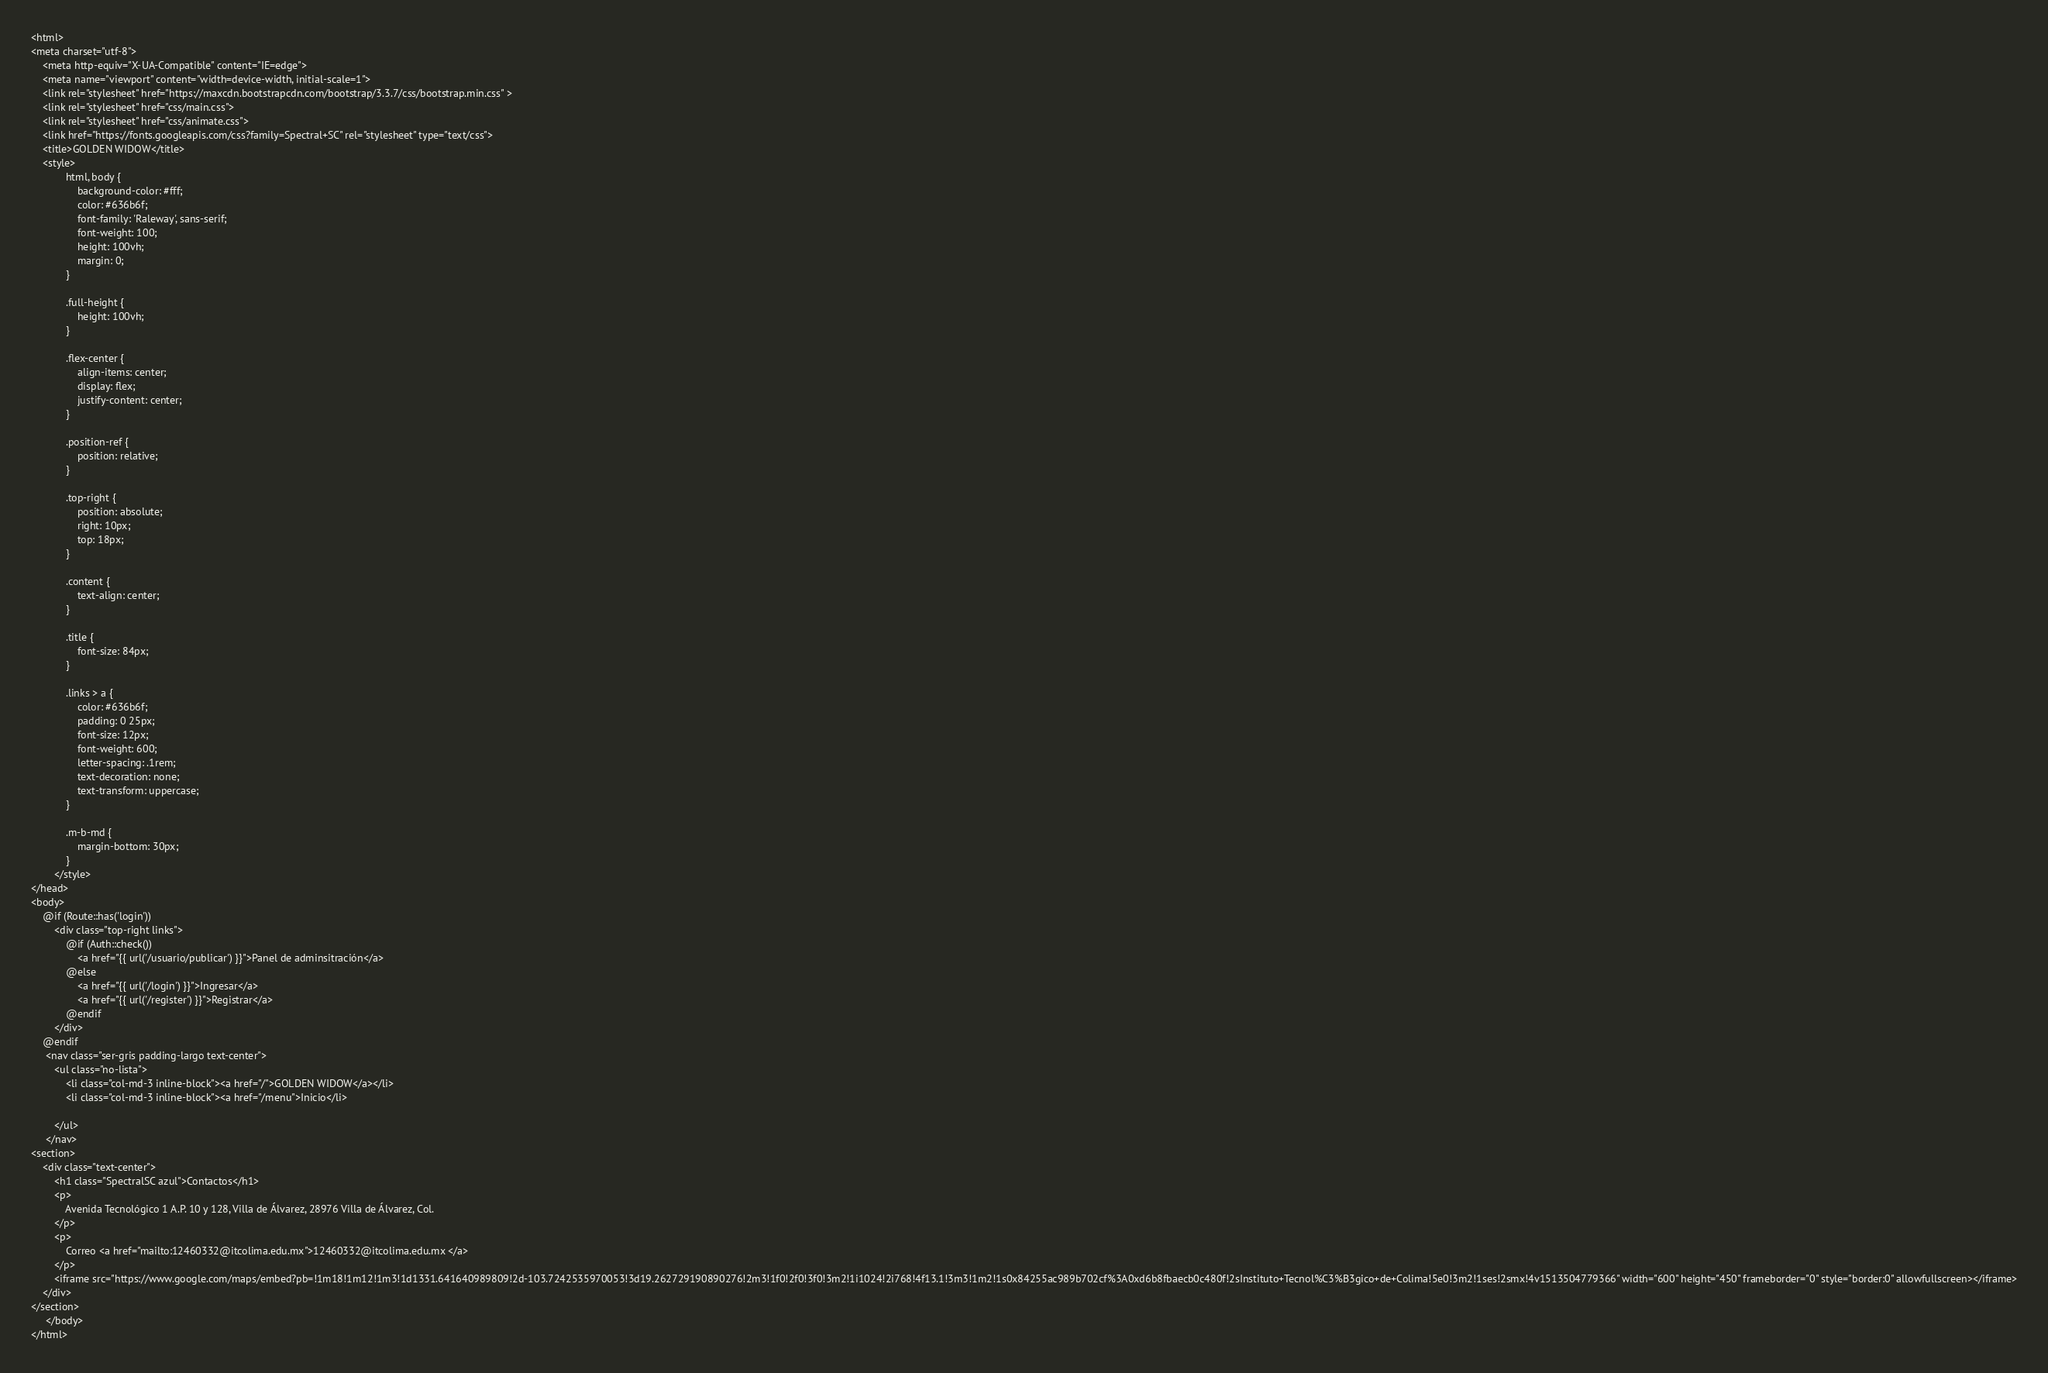<code> <loc_0><loc_0><loc_500><loc_500><_PHP_><html>
<meta charset="utf-8">
    <meta http-equiv="X-UA-Compatible" content="IE=edge">
    <meta name="viewport" content="width=device-width, initial-scale=1">
    <link rel="stylesheet" href="https://maxcdn.bootstrapcdn.com/bootstrap/3.3.7/css/bootstrap.min.css" >
    <link rel="stylesheet" href="css/main.css">
    <link rel="stylesheet" href="css/animate.css">
    <link href="https://fonts.googleapis.com/css?family=Spectral+SC" rel="stylesheet" type="text/css">
    <title>GOLDEN WIDOW</title>  
    <style>
            html, body {
                background-color: #fff;
                color: #636b6f;
                font-family: 'Raleway', sans-serif;
                font-weight: 100;
                height: 100vh;
                margin: 0;
            }

            .full-height {
                height: 100vh;
            }

            .flex-center {
                align-items: center;
                display: flex;
                justify-content: center;
            }

            .position-ref {
                position: relative;
            }

            .top-right {
                position: absolute;
                right: 10px;
                top: 18px;
            }

            .content {
                text-align: center;
            }

            .title {
                font-size: 84px;
            }

            .links > a {
                color: #636b6f;
                padding: 0 25px;
                font-size: 12px;
                font-weight: 600;
                letter-spacing: .1rem;
                text-decoration: none;
                text-transform: uppercase;
            }

            .m-b-md {
                margin-bottom: 30px;
            }
        </style>       
</head>
<body>
    @if (Route::has('login'))
        <div class="top-right links">
            @if (Auth::check())
                <a href="{{ url('/usuario/publicar') }}">Panel de adminsitración</a>
            @else
                <a href="{{ url('/login') }}">Ingresar</a>
                <a href="{{ url('/register') }}">Registrar</a>
            @endif
        </div>
    @endif
     <nav class="ser-gris padding-largo text-center">
     	<ul class="no-lista">
     		<li class="col-md-3 inline-block"><a href="/">GOLDEN WIDOW</a></li>
     		<li class="col-md-3 inline-block"><a href="/menu">Inicio</li>

     	</ul>
     </nav>
<section>
    <div class="text-center">
        <h1 class="SpectralSC azul">Contactos</h1>
        <p>
            Avenida Tecnológico 1 A.P. 10 y 128, Villa de Álvarez, 28976 Villa de Álvarez, Col.
        </p>
        <p>
            Correo <a href="mailto:12460332@itcolima.edu.mx">12460332@itcolima.edu.mx </a>
        </p>
        <iframe src="https://www.google.com/maps/embed?pb=!1m18!1m12!1m3!1d1331.641640989809!2d-103.7242535970053!3d19.262729190890276!2m3!1f0!2f0!3f0!3m2!1i1024!2i768!4f13.1!3m3!1m2!1s0x84255ac989b702cf%3A0xd6b8fbaecb0c480f!2sInstituto+Tecnol%C3%B3gico+de+Colima!5e0!3m2!1ses!2smx!4v1513504779366" width="600" height="450" frameborder="0" style="border:0" allowfullscreen></iframe>
    </div>
</section>
     </body>
</html></code> 